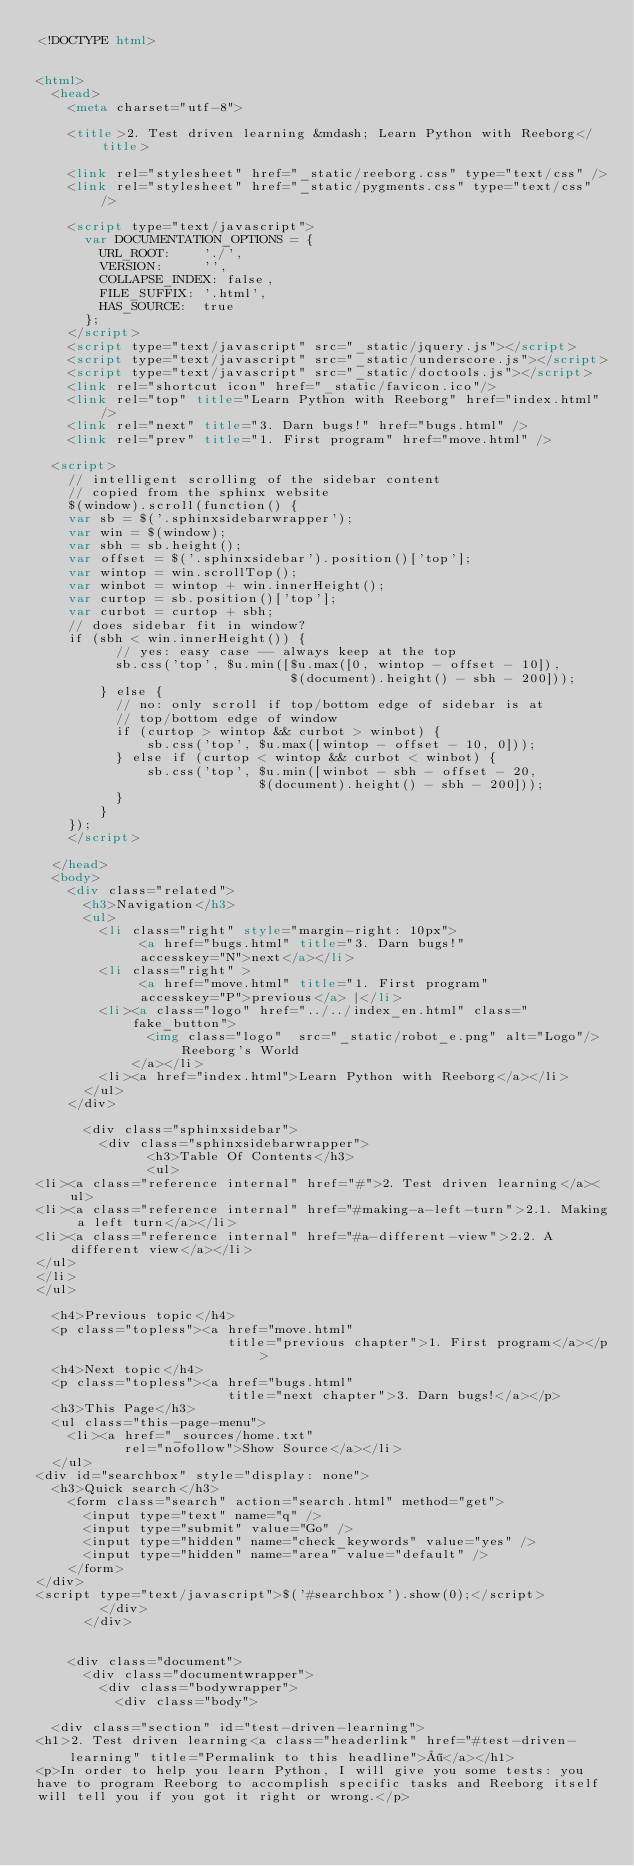Convert code to text. <code><loc_0><loc_0><loc_500><loc_500><_HTML_><!DOCTYPE html>


<html>
  <head>
    <meta charset="utf-8"> 
    
    <title>2. Test driven learning &mdash; Learn Python with Reeborg</title>
    
    <link rel="stylesheet" href="_static/reeborg.css" type="text/css" />
    <link rel="stylesheet" href="_static/pygments.css" type="text/css" />
    
    <script type="text/javascript">
      var DOCUMENTATION_OPTIONS = {
        URL_ROOT:    './',
        VERSION:     '',
        COLLAPSE_INDEX: false,
        FILE_SUFFIX: '.html',
        HAS_SOURCE:  true
      };
    </script>
    <script type="text/javascript" src="_static/jquery.js"></script>
    <script type="text/javascript" src="_static/underscore.js"></script>
    <script type="text/javascript" src="_static/doctools.js"></script>
    <link rel="shortcut icon" href="_static/favicon.ico"/>
    <link rel="top" title="Learn Python with Reeborg" href="index.html" />
    <link rel="next" title="3. Darn bugs!" href="bugs.html" />
    <link rel="prev" title="1. First program" href="move.html" /> 
  
  <script>
    // intelligent scrolling of the sidebar content
    // copied from the sphinx website
    $(window).scroll(function() {
    var sb = $('.sphinxsidebarwrapper');
    var win = $(window);
    var sbh = sb.height();
    var offset = $('.sphinxsidebar').position()['top'];
    var wintop = win.scrollTop();
    var winbot = wintop + win.innerHeight();
    var curtop = sb.position()['top'];
    var curbot = curtop + sbh;
    // does sidebar fit in window?
    if (sbh < win.innerHeight()) {
          // yes: easy case -- always keep at the top
          sb.css('top', $u.min([$u.max([0, wintop - offset - 10]),
                                $(document).height() - sbh - 200]));
        } else {
          // no: only scroll if top/bottom edge of sidebar is at
          // top/bottom edge of window
          if (curtop > wintop && curbot > winbot) {
              sb.css('top', $u.max([wintop - offset - 10, 0]));
          } else if (curtop < wintop && curbot < winbot) {
              sb.css('top', $u.min([winbot - sbh - offset - 20,
                            $(document).height() - sbh - 200]));
          }
        }
    });
    </script>
  
  </head>
  <body>
    <div class="related">
      <h3>Navigation</h3>
      <ul>
        <li class="right" style="margin-right: 10px">
             <a href="bugs.html" title="3. Darn bugs!"
             accesskey="N">next</a></li>
        <li class="right" >
             <a href="move.html" title="1. First program"
             accesskey="P">previous</a> |</li>
        <li><a class="logo" href="../../index_en.html" class="fake_button">
              <img class="logo"  src="_static/robot_e.png" alt="Logo"/>Reeborg's World
            </a></li>
        <li><a href="index.html">Learn Python with Reeborg</a></li> 
      </ul>
    </div>
  
      <div class="sphinxsidebar">
        <div class="sphinxsidebarwrapper">
              <h3>Table Of Contents</h3>
              <ul>
<li><a class="reference internal" href="#">2. Test driven learning</a><ul>
<li><a class="reference internal" href="#making-a-left-turn">2.1. Making a left turn</a></li>
<li><a class="reference internal" href="#a-different-view">2.2. A different view</a></li>
</ul>
</li>
</ul>

  <h4>Previous topic</h4>
  <p class="topless"><a href="move.html"
                        title="previous chapter">1. First program</a></p>
  <h4>Next topic</h4>
  <p class="topless"><a href="bugs.html"
                        title="next chapter">3. Darn bugs!</a></p>
  <h3>This Page</h3>
  <ul class="this-page-menu">
    <li><a href="_sources/home.txt"
           rel="nofollow">Show Source</a></li>
  </ul>
<div id="searchbox" style="display: none">
  <h3>Quick search</h3>
    <form class="search" action="search.html" method="get">
      <input type="text" name="q" />
      <input type="submit" value="Go" />
      <input type="hidden" name="check_keywords" value="yes" />
      <input type="hidden" name="area" value="default" />
    </form>
</div>
<script type="text/javascript">$('#searchbox').show(0);</script>
        </div>
      </div>


    <div class="document">
      <div class="documentwrapper">
        <div class="bodywrapper">
          <div class="body">
            
  <div class="section" id="test-driven-learning">
<h1>2. Test driven learning<a class="headerlink" href="#test-driven-learning" title="Permalink to this headline">¶</a></h1>
<p>In order to help you learn Python, I will give you some tests: you
have to program Reeborg to accomplish specific tasks and Reeborg itself
will tell you if you got it right or wrong.</p></code> 